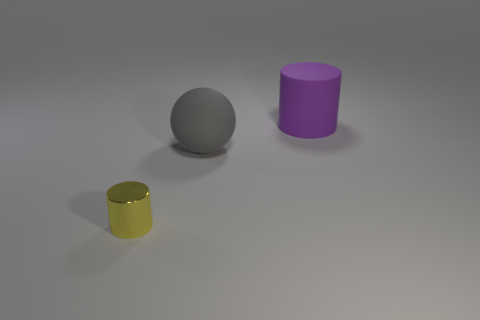How many purple rubber cylinders are behind the cylinder that is behind the yellow metallic thing? There are 0 purple rubber cylinders behind the cylinder that is directly behind the yellow metallic cylinder. The only objects visible are a silver sphere, a purple cylinder directly in front, and the yellow metallic cylinder. 